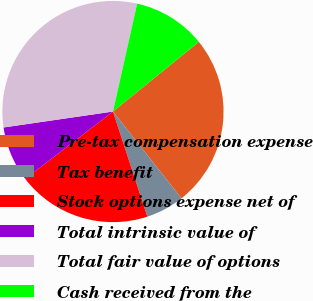Convert chart to OTSL. <chart><loc_0><loc_0><loc_500><loc_500><pie_chart><fcel>Pre-tax compensation expense<fcel>Tax benefit<fcel>Stock options expense net of<fcel>Total intrinsic value of<fcel>Total fair value of options<fcel>Cash received from the<nl><fcel>25.21%<fcel>5.6%<fcel>19.61%<fcel>8.12%<fcel>30.81%<fcel>10.64%<nl></chart> 